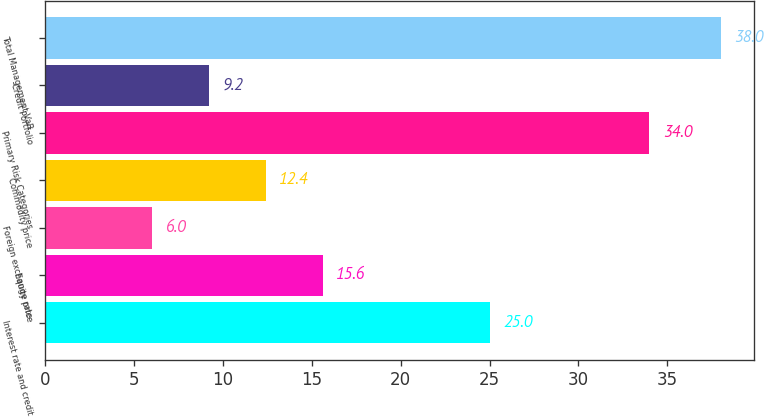Convert chart. <chart><loc_0><loc_0><loc_500><loc_500><bar_chart><fcel>Interest rate and credit<fcel>Equity price<fcel>Foreign exchange rate<fcel>Commodity price<fcel>Primary Risk Categories<fcel>Credit Portfolio<fcel>Total Management VaR<nl><fcel>25<fcel>15.6<fcel>6<fcel>12.4<fcel>34<fcel>9.2<fcel>38<nl></chart> 